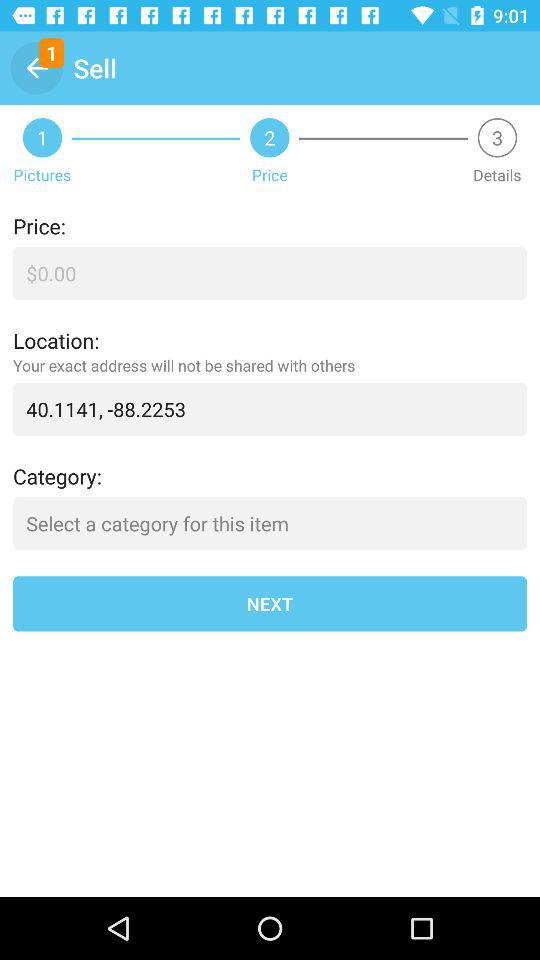How many new notifications are there in "Sell"? There is 1 new notification. 